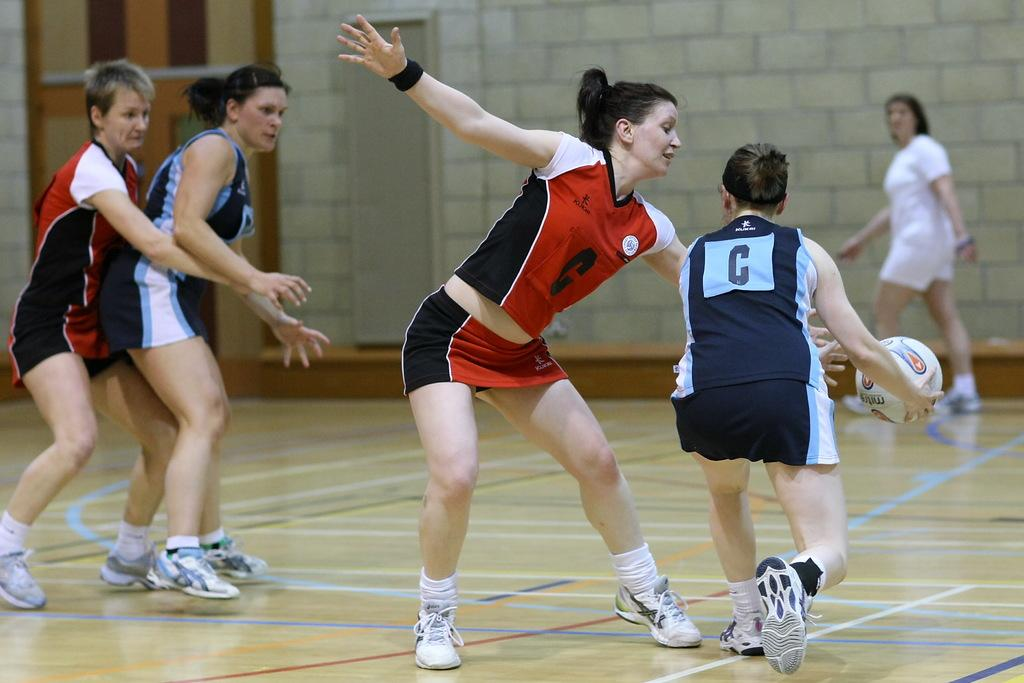<image>
Relay a brief, clear account of the picture shown. the letter C is on the back of a player 